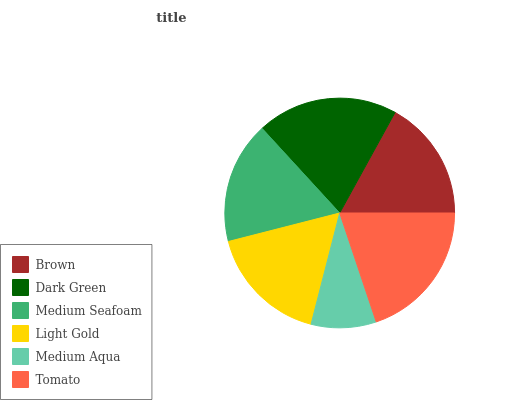Is Medium Aqua the minimum?
Answer yes or no. Yes. Is Tomato the maximum?
Answer yes or no. Yes. Is Dark Green the minimum?
Answer yes or no. No. Is Dark Green the maximum?
Answer yes or no. No. Is Dark Green greater than Brown?
Answer yes or no. Yes. Is Brown less than Dark Green?
Answer yes or no. Yes. Is Brown greater than Dark Green?
Answer yes or no. No. Is Dark Green less than Brown?
Answer yes or no. No. Is Medium Seafoam the high median?
Answer yes or no. Yes. Is Light Gold the low median?
Answer yes or no. Yes. Is Tomato the high median?
Answer yes or no. No. Is Tomato the low median?
Answer yes or no. No. 